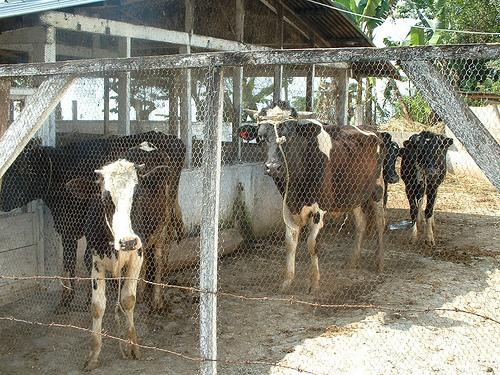The nearby cow to the left who is looking at the camera wears what color down his face?

Choices:
A) white
B) brown
C) black
D) gray white 